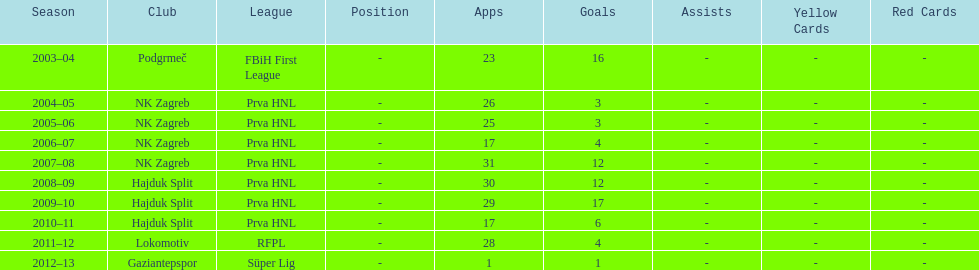Did ibricic score more or less goals in his 3 seasons with hajduk split when compared to his 4 seasons with nk zagreb? More. 